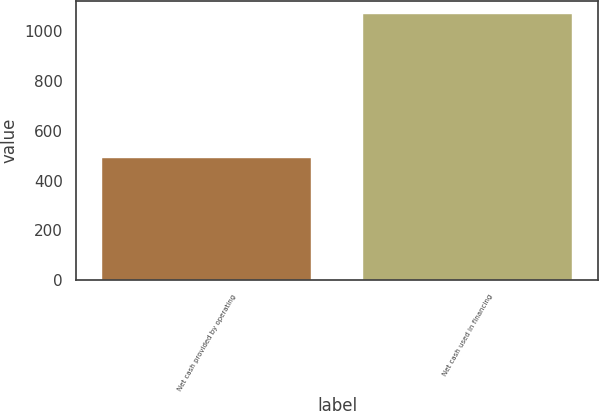Convert chart to OTSL. <chart><loc_0><loc_0><loc_500><loc_500><bar_chart><fcel>Net cash provided by operating<fcel>Net cash used in financing<nl><fcel>491<fcel>1068<nl></chart> 